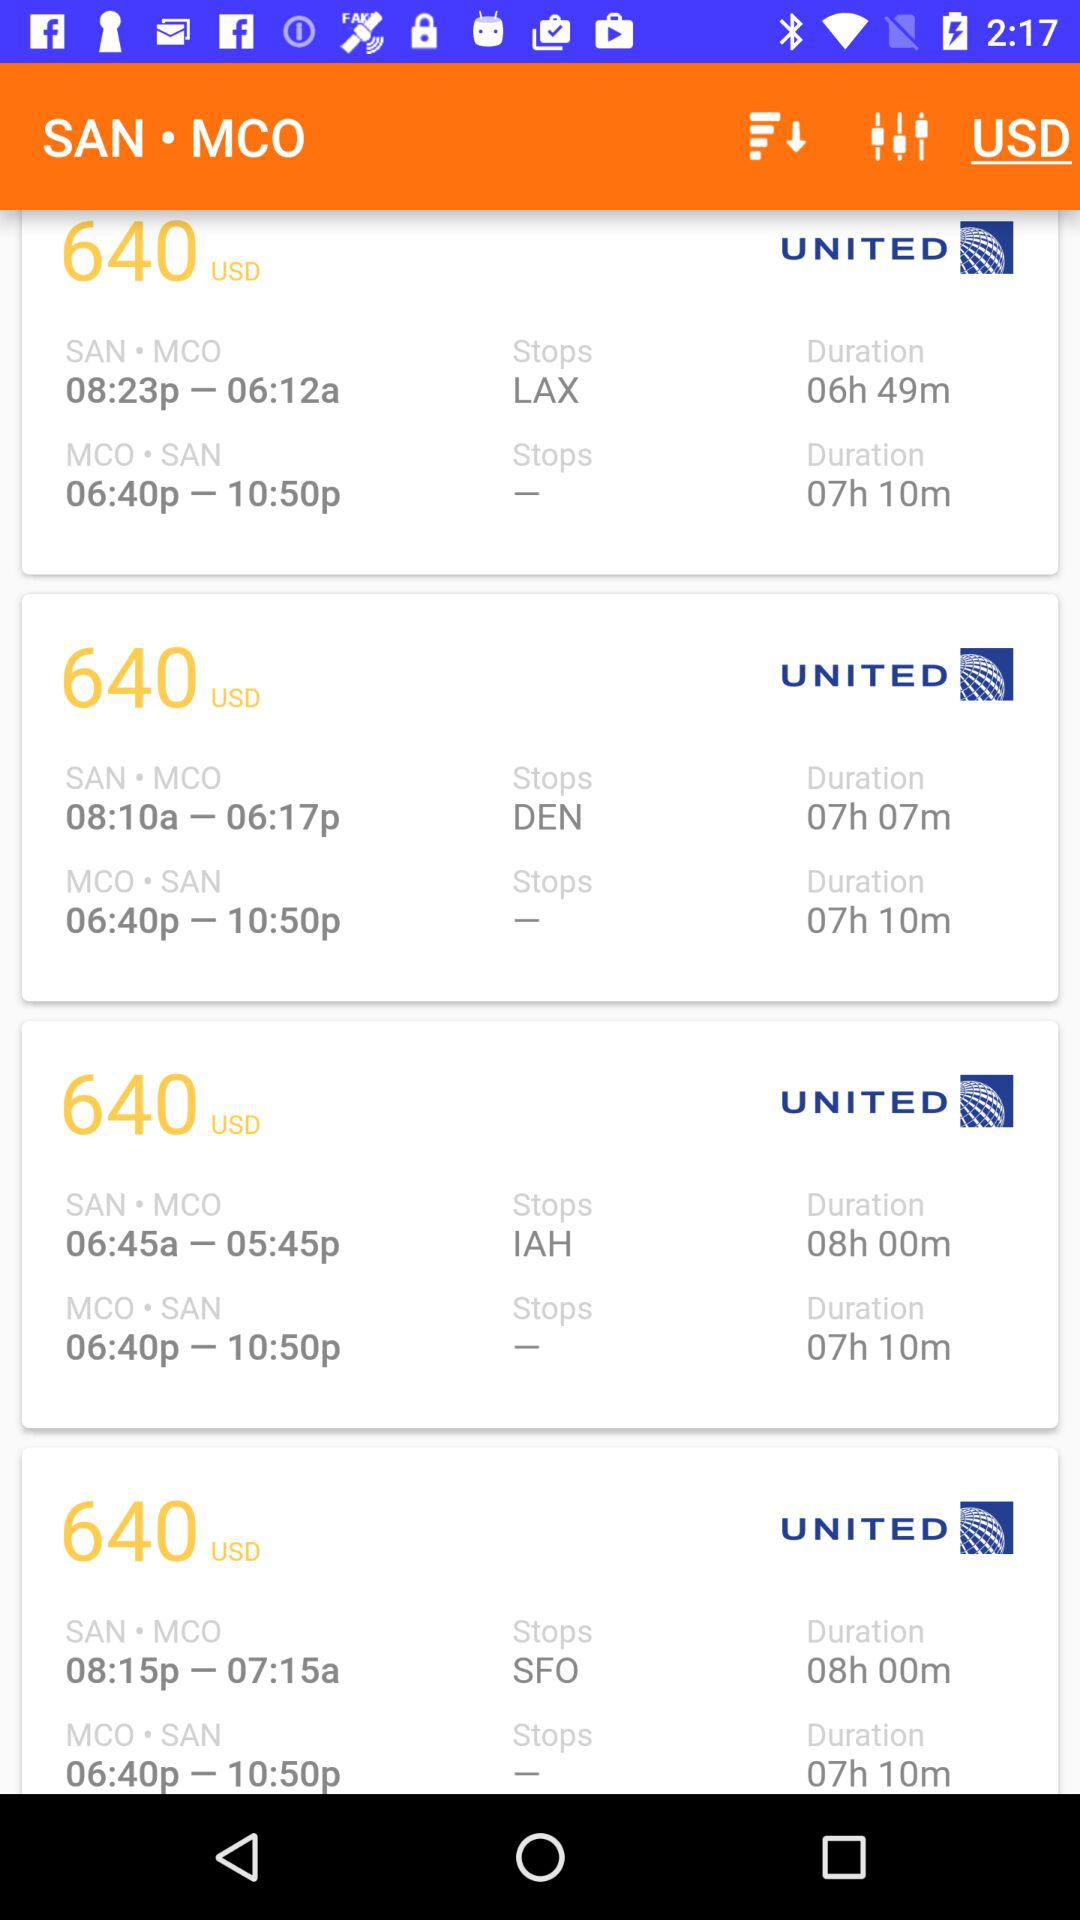What is the journey time between SAN and MCO with DEN as a layover? The journey time between SAN and MCO with DEN as a layover is 7 hours 7 minutes. 